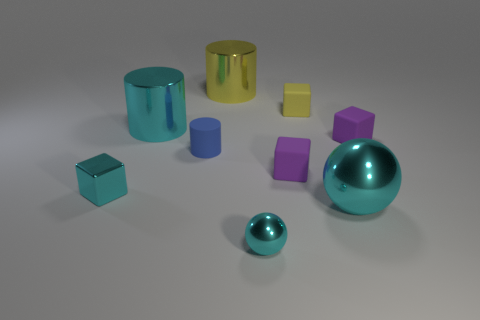What size is the cyan metallic object that is both left of the small cylinder and right of the shiny cube?
Offer a very short reply. Large. How many metal blocks have the same size as the yellow cylinder?
Provide a short and direct response. 0. There is a large yellow thing that is the same shape as the tiny blue thing; what is it made of?
Give a very brief answer. Metal. Is the shape of the tiny blue thing the same as the yellow rubber object?
Offer a terse response. No. There is a small cyan shiny ball; what number of cyan shiny things are behind it?
Your answer should be compact. 3. There is a cyan metal object that is right of the small shiny thing on the right side of the big yellow metallic object; what is its shape?
Give a very brief answer. Sphere. What shape is the small yellow object that is made of the same material as the tiny blue cylinder?
Make the answer very short. Cube. Is the size of the cyan object that is behind the cyan metal block the same as the rubber cylinder that is to the right of the small cyan metallic cube?
Offer a terse response. No. What is the shape of the purple matte thing that is behind the blue matte thing?
Offer a terse response. Cube. What color is the tiny sphere?
Offer a terse response. Cyan. 